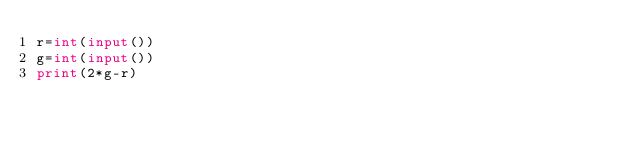<code> <loc_0><loc_0><loc_500><loc_500><_Python_>r=int(input())
g=int(input())
print(2*g-r)
  </code> 